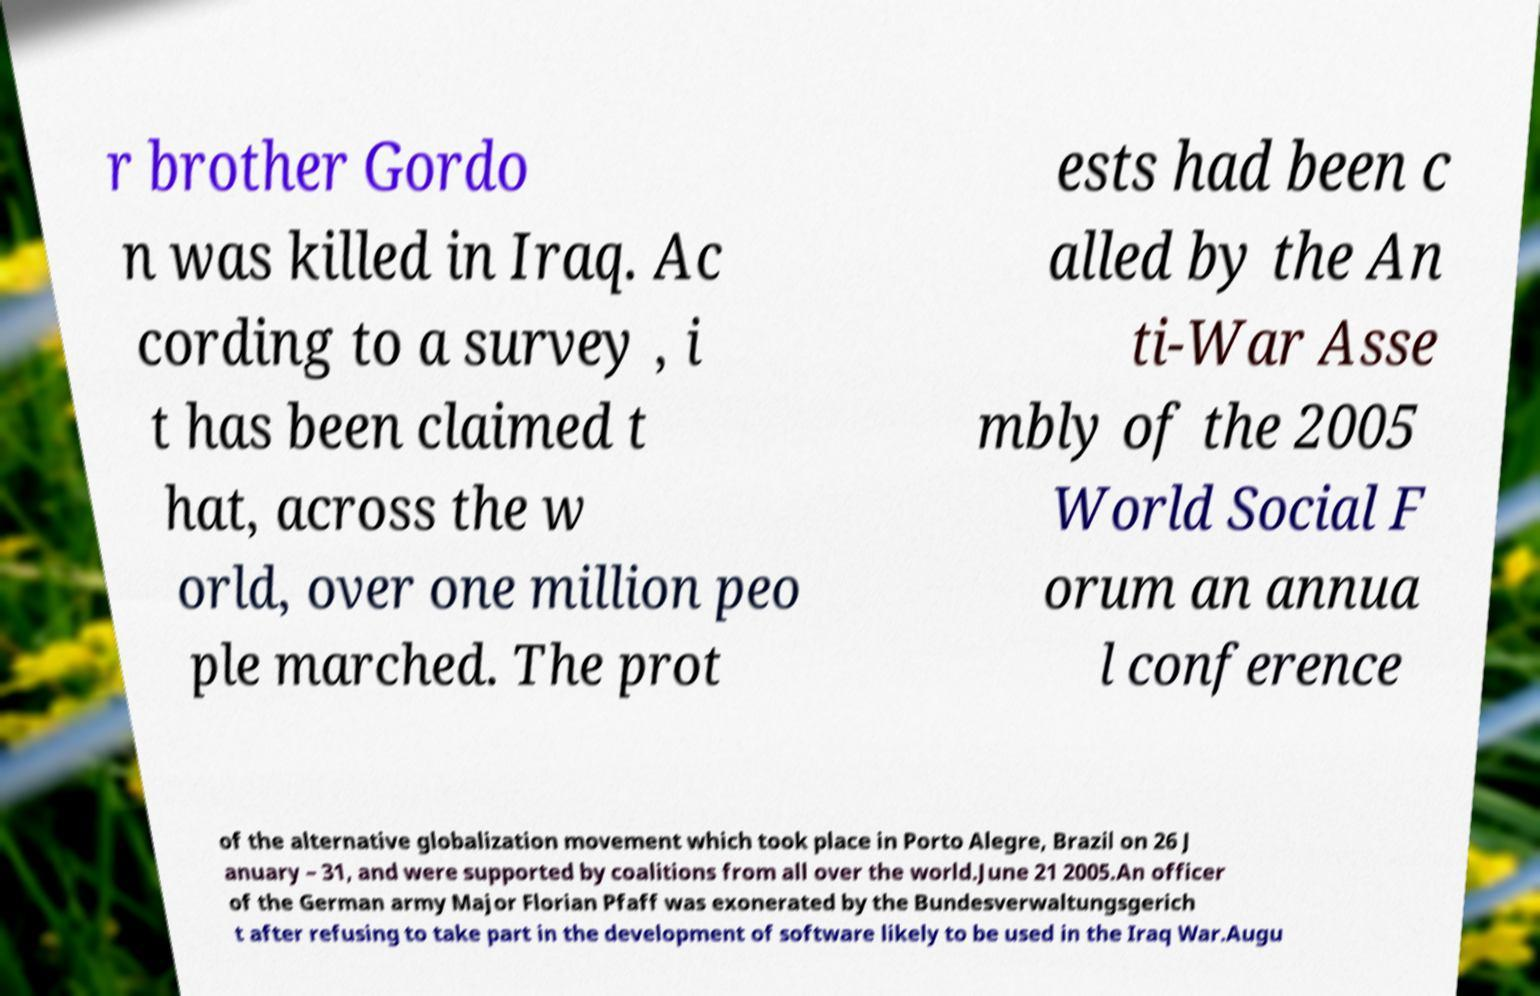Please identify and transcribe the text found in this image. r brother Gordo n was killed in Iraq. Ac cording to a survey , i t has been claimed t hat, across the w orld, over one million peo ple marched. The prot ests had been c alled by the An ti-War Asse mbly of the 2005 World Social F orum an annua l conference of the alternative globalization movement which took place in Porto Alegre, Brazil on 26 J anuary – 31, and were supported by coalitions from all over the world.June 21 2005.An officer of the German army Major Florian Pfaff was exonerated by the Bundesverwaltungsgerich t after refusing to take part in the development of software likely to be used in the Iraq War.Augu 